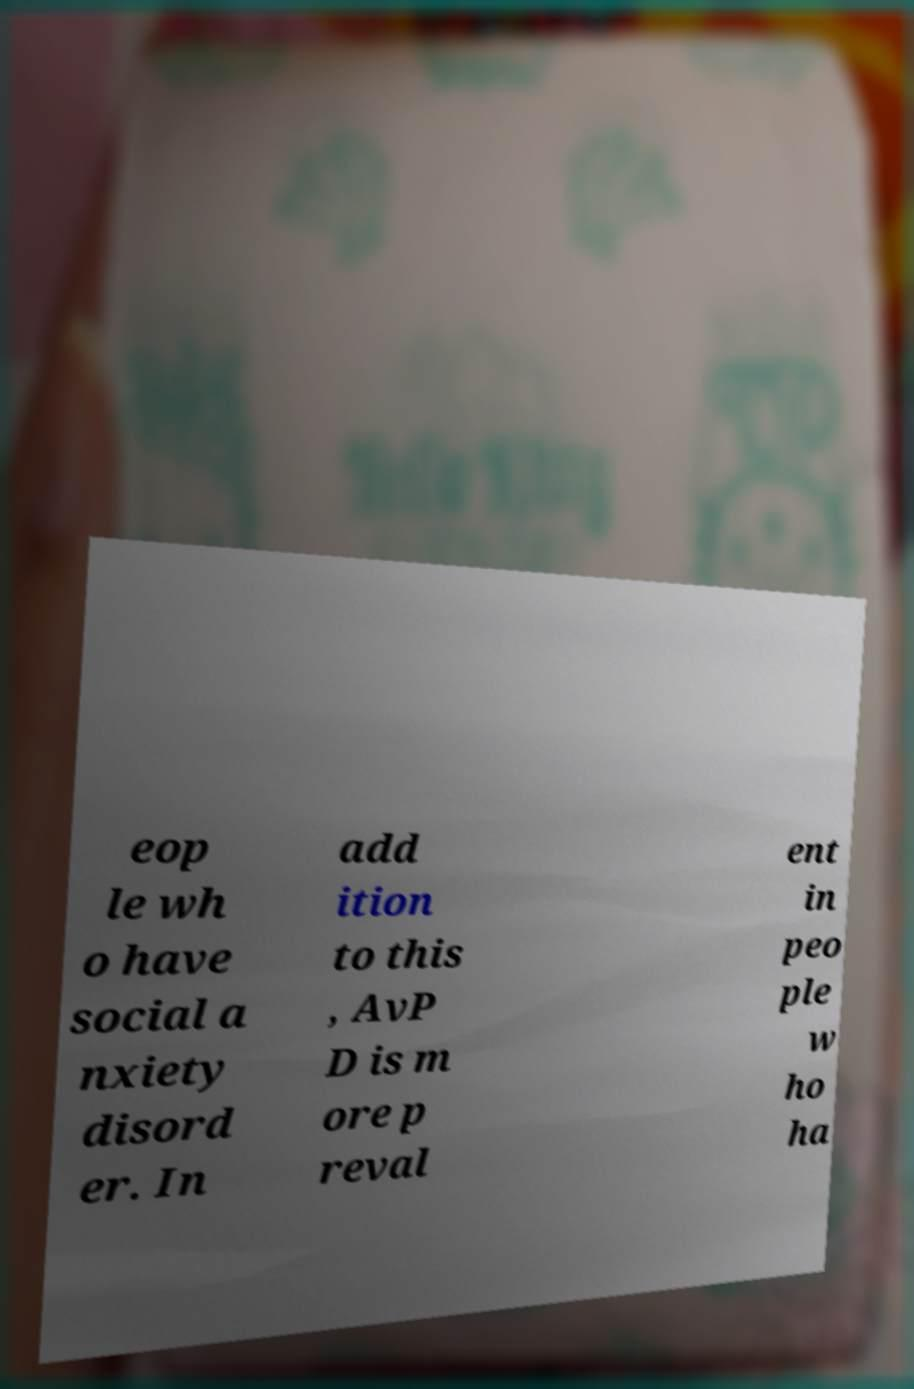For documentation purposes, I need the text within this image transcribed. Could you provide that? eop le wh o have social a nxiety disord er. In add ition to this , AvP D is m ore p reval ent in peo ple w ho ha 